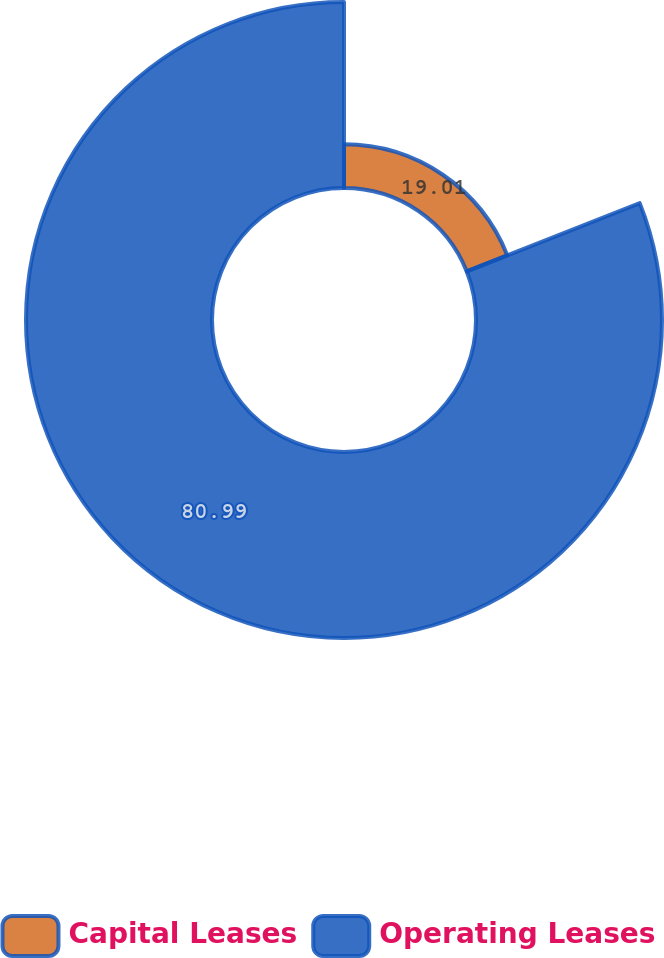<chart> <loc_0><loc_0><loc_500><loc_500><pie_chart><fcel>Capital Leases<fcel>Operating Leases<nl><fcel>19.01%<fcel>80.99%<nl></chart> 